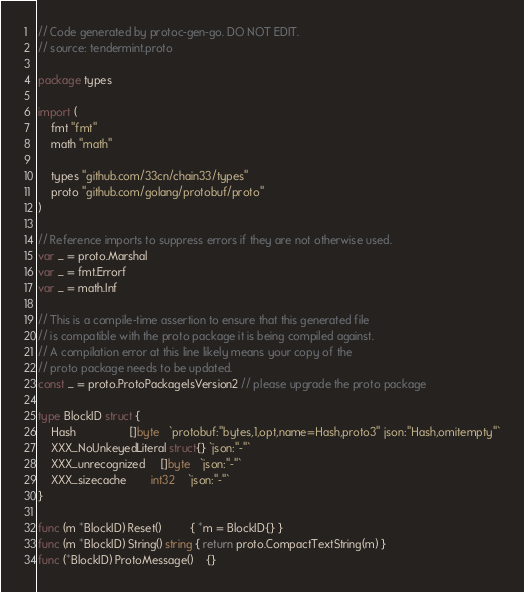<code> <loc_0><loc_0><loc_500><loc_500><_Go_>// Code generated by protoc-gen-go. DO NOT EDIT.
// source: tendermint.proto

package types

import (
	fmt "fmt"
	math "math"

	types "github.com/33cn/chain33/types"
	proto "github.com/golang/protobuf/proto"
)

// Reference imports to suppress errors if they are not otherwise used.
var _ = proto.Marshal
var _ = fmt.Errorf
var _ = math.Inf

// This is a compile-time assertion to ensure that this generated file
// is compatible with the proto package it is being compiled against.
// A compilation error at this line likely means your copy of the
// proto package needs to be updated.
const _ = proto.ProtoPackageIsVersion2 // please upgrade the proto package

type BlockID struct {
	Hash                 []byte   `protobuf:"bytes,1,opt,name=Hash,proto3" json:"Hash,omitempty"`
	XXX_NoUnkeyedLiteral struct{} `json:"-"`
	XXX_unrecognized     []byte   `json:"-"`
	XXX_sizecache        int32    `json:"-"`
}

func (m *BlockID) Reset()         { *m = BlockID{} }
func (m *BlockID) String() string { return proto.CompactTextString(m) }
func (*BlockID) ProtoMessage()    {}</code> 